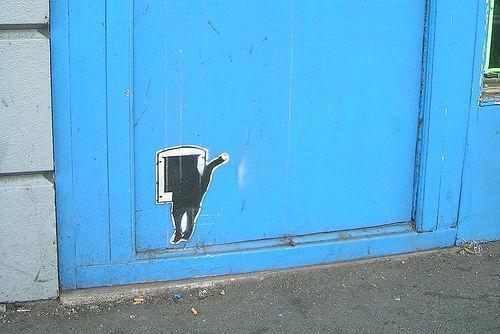How many doors are in the picture?
Give a very brief answer. 1. How many cat legs are visible?
Give a very brief answer. 2. How many doors are shown?
Give a very brief answer. 1. How many people are shown?
Give a very brief answer. 0. 